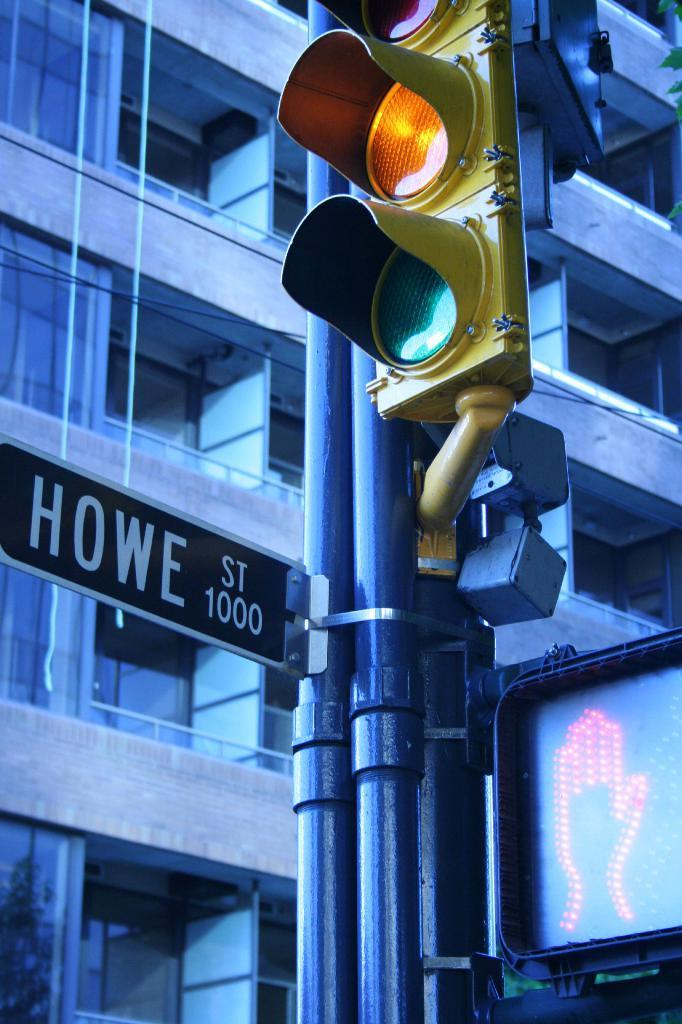<image>
Provide a brief description of the given image. The traffic light at Howe Street is yellow. 